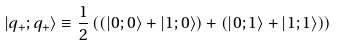<formula> <loc_0><loc_0><loc_500><loc_500>| q _ { + } ; q _ { + } \rangle \equiv \frac { 1 } { 2 } \left ( ( | 0 ; 0 \rangle + | 1 ; 0 \rangle ) + ( | 0 ; 1 \rangle + | 1 ; 1 \rangle ) \right )</formula> 